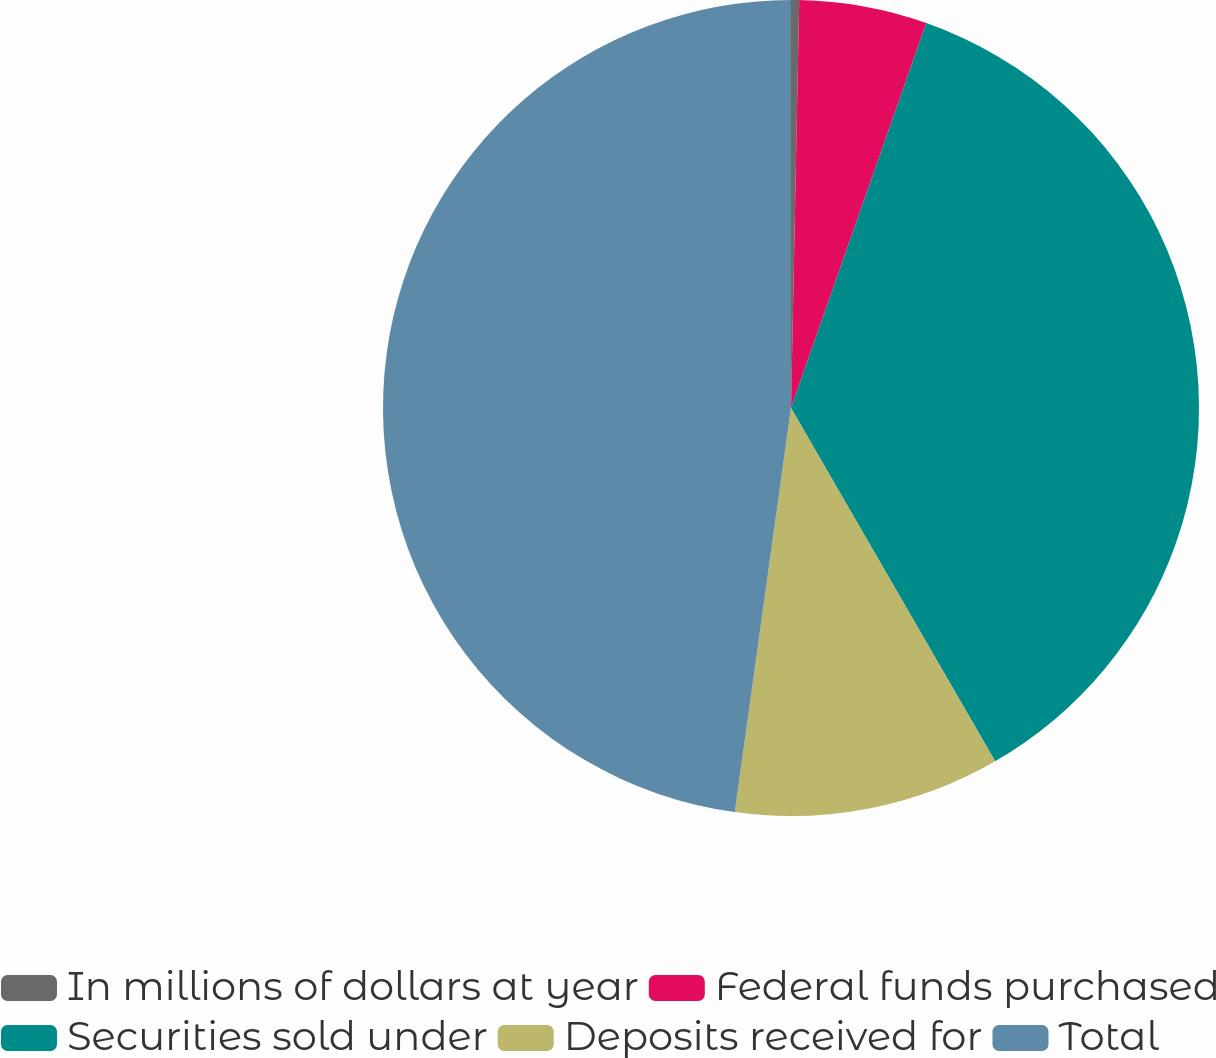Convert chart to OTSL. <chart><loc_0><loc_0><loc_500><loc_500><pie_chart><fcel>In millions of dollars at year<fcel>Federal funds purchased<fcel>Securities sold under<fcel>Deposits received for<fcel>Total<nl><fcel>0.32%<fcel>5.06%<fcel>36.28%<fcel>10.54%<fcel>47.8%<nl></chart> 